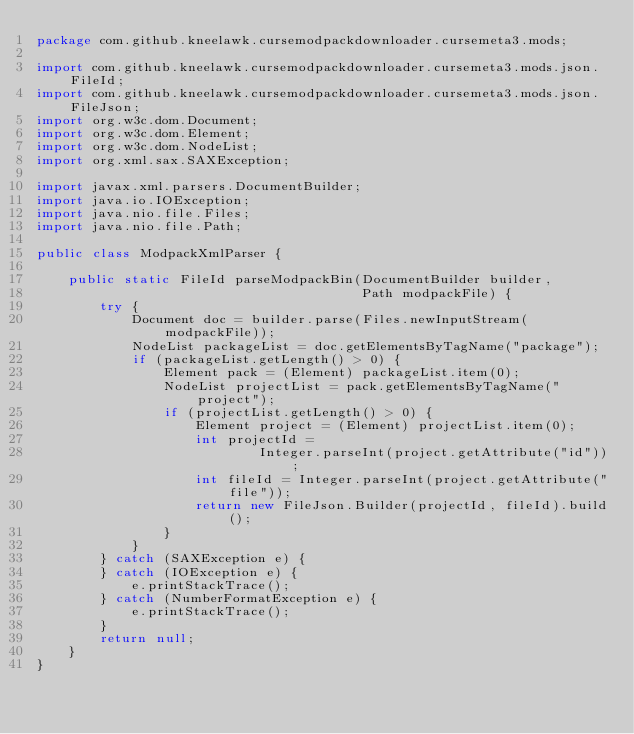<code> <loc_0><loc_0><loc_500><loc_500><_Java_>package com.github.kneelawk.cursemodpackdownloader.cursemeta3.mods;

import com.github.kneelawk.cursemodpackdownloader.cursemeta3.mods.json.FileId;
import com.github.kneelawk.cursemodpackdownloader.cursemeta3.mods.json.FileJson;
import org.w3c.dom.Document;
import org.w3c.dom.Element;
import org.w3c.dom.NodeList;
import org.xml.sax.SAXException;

import javax.xml.parsers.DocumentBuilder;
import java.io.IOException;
import java.nio.file.Files;
import java.nio.file.Path;

public class ModpackXmlParser {

    public static FileId parseModpackBin(DocumentBuilder builder,
                                         Path modpackFile) {
        try {
            Document doc = builder.parse(Files.newInputStream(modpackFile));
            NodeList packageList = doc.getElementsByTagName("package");
            if (packageList.getLength() > 0) {
                Element pack = (Element) packageList.item(0);
                NodeList projectList = pack.getElementsByTagName("project");
                if (projectList.getLength() > 0) {
                    Element project = (Element) projectList.item(0);
                    int projectId =
                            Integer.parseInt(project.getAttribute("id"));
                    int fileId = Integer.parseInt(project.getAttribute("file"));
                    return new FileJson.Builder(projectId, fileId).build();
                }
            }
        } catch (SAXException e) {
        } catch (IOException e) {
            e.printStackTrace();
        } catch (NumberFormatException e) {
            e.printStackTrace();
        }
        return null;
    }
}
</code> 